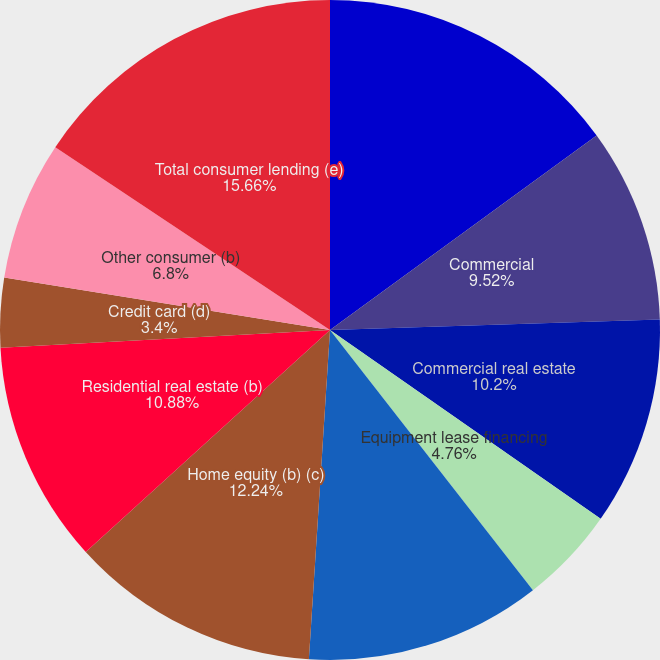Convert chart. <chart><loc_0><loc_0><loc_500><loc_500><pie_chart><fcel>December 31 - dollars in<fcel>Commercial<fcel>Commercial real estate<fcel>Equipment lease financing<fcel>Total commercial lending<fcel>Home equity (b) (c)<fcel>Residential real estate (b)<fcel>Credit card (d)<fcel>Other consumer (b)<fcel>Total consumer lending (e)<nl><fcel>14.97%<fcel>9.52%<fcel>10.2%<fcel>4.76%<fcel>11.56%<fcel>12.24%<fcel>10.88%<fcel>3.4%<fcel>6.8%<fcel>15.65%<nl></chart> 